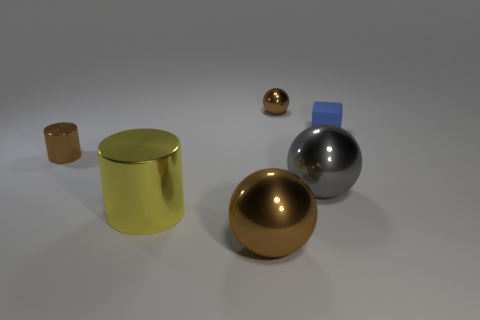Is there any other thing of the same color as the tiny shiny sphere?
Offer a terse response. Yes. Do the small metallic ball and the small cylinder have the same color?
Offer a very short reply. Yes. What is the shape of the small object that is the same color as the small shiny sphere?
Provide a succinct answer. Cylinder. There is a brown metallic thing that is behind the brown metallic cylinder; what is its shape?
Make the answer very short. Sphere. What is the size of the yellow thing that is the same material as the big brown ball?
Offer a terse response. Large. What is the shape of the object that is both behind the gray shiny ball and right of the tiny metallic ball?
Provide a succinct answer. Cube. There is a ball in front of the big gray sphere; does it have the same color as the tiny metal cylinder?
Ensure brevity in your answer.  Yes. Is the shape of the big thing that is on the right side of the tiny brown ball the same as the brown metal thing that is left of the yellow cylinder?
Make the answer very short. No. How big is the yellow metal object left of the tiny cube?
Your response must be concise. Large. What is the size of the brown shiny ball that is on the right side of the ball that is in front of the gray thing?
Ensure brevity in your answer.  Small. 